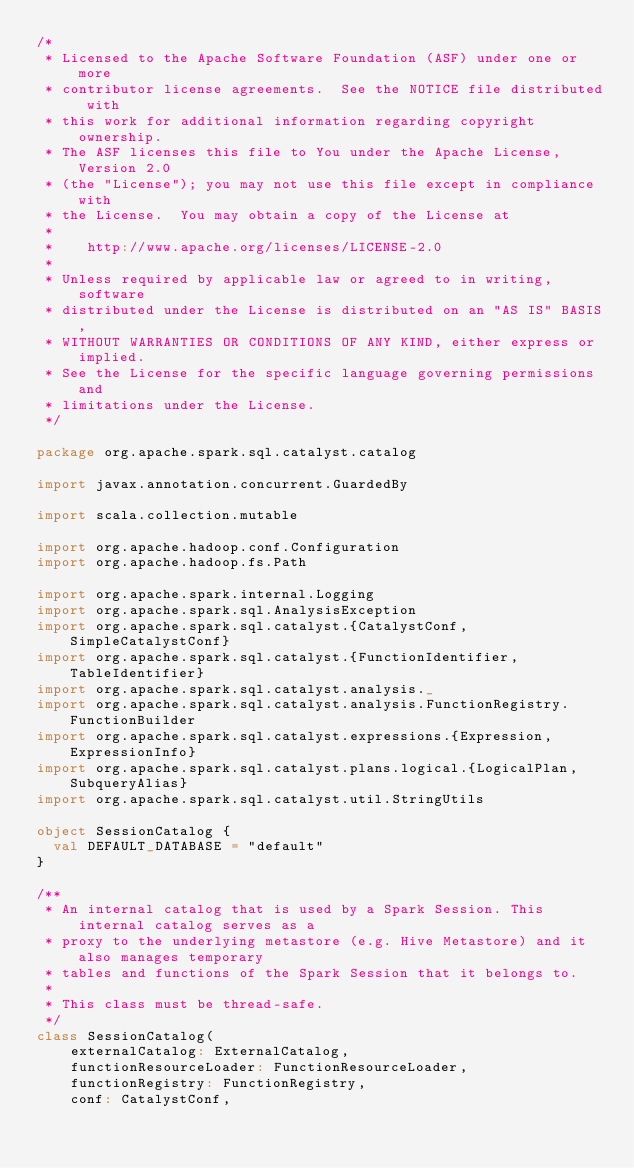Convert code to text. <code><loc_0><loc_0><loc_500><loc_500><_Scala_>/*
 * Licensed to the Apache Software Foundation (ASF) under one or more
 * contributor license agreements.  See the NOTICE file distributed with
 * this work for additional information regarding copyright ownership.
 * The ASF licenses this file to You under the Apache License, Version 2.0
 * (the "License"); you may not use this file except in compliance with
 * the License.  You may obtain a copy of the License at
 *
 *    http://www.apache.org/licenses/LICENSE-2.0
 *
 * Unless required by applicable law or agreed to in writing, software
 * distributed under the License is distributed on an "AS IS" BASIS,
 * WITHOUT WARRANTIES OR CONDITIONS OF ANY KIND, either express or implied.
 * See the License for the specific language governing permissions and
 * limitations under the License.
 */

package org.apache.spark.sql.catalyst.catalog

import javax.annotation.concurrent.GuardedBy

import scala.collection.mutable

import org.apache.hadoop.conf.Configuration
import org.apache.hadoop.fs.Path

import org.apache.spark.internal.Logging
import org.apache.spark.sql.AnalysisException
import org.apache.spark.sql.catalyst.{CatalystConf, SimpleCatalystConf}
import org.apache.spark.sql.catalyst.{FunctionIdentifier, TableIdentifier}
import org.apache.spark.sql.catalyst.analysis._
import org.apache.spark.sql.catalyst.analysis.FunctionRegistry.FunctionBuilder
import org.apache.spark.sql.catalyst.expressions.{Expression, ExpressionInfo}
import org.apache.spark.sql.catalyst.plans.logical.{LogicalPlan, SubqueryAlias}
import org.apache.spark.sql.catalyst.util.StringUtils

object SessionCatalog {
  val DEFAULT_DATABASE = "default"
}

/**
 * An internal catalog that is used by a Spark Session. This internal catalog serves as a
 * proxy to the underlying metastore (e.g. Hive Metastore) and it also manages temporary
 * tables and functions of the Spark Session that it belongs to.
 *
 * This class must be thread-safe.
 */
class SessionCatalog(
    externalCatalog: ExternalCatalog,
    functionResourceLoader: FunctionResourceLoader,
    functionRegistry: FunctionRegistry,
    conf: CatalystConf,</code> 